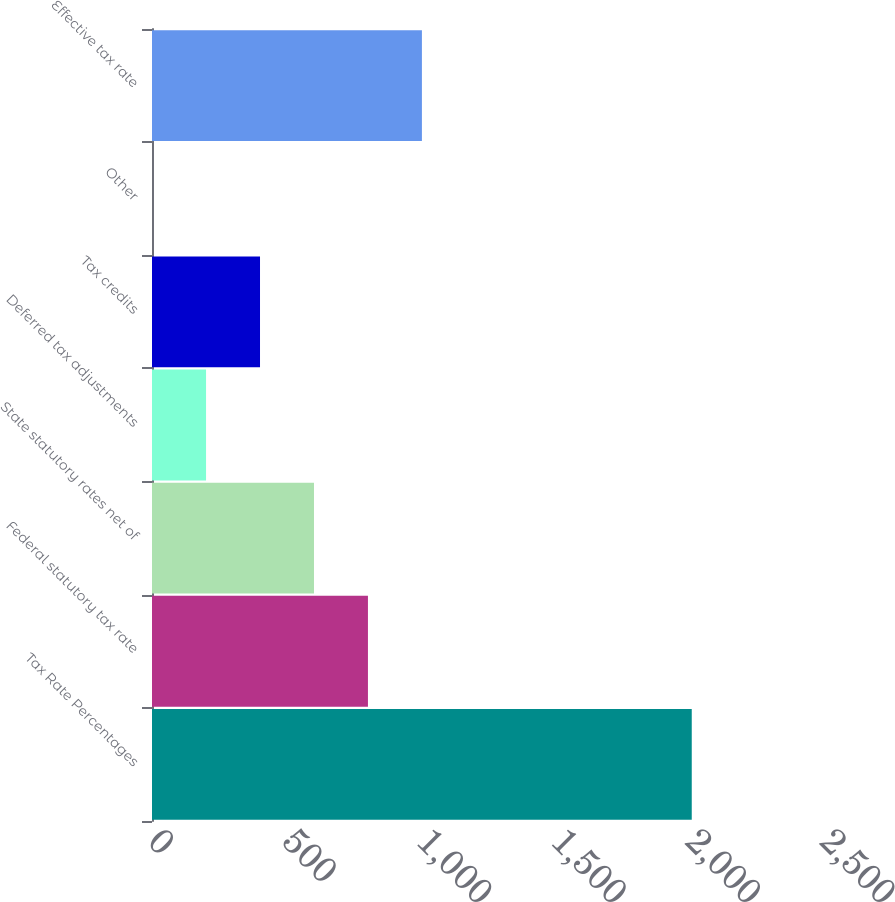<chart> <loc_0><loc_0><loc_500><loc_500><bar_chart><fcel>Tax Rate Percentages<fcel>Federal statutory tax rate<fcel>State statutory rates net of<fcel>Deferred tax adjustments<fcel>Tax credits<fcel>Other<fcel>Effective tax rate<nl><fcel>2008<fcel>803.38<fcel>602.61<fcel>201.07<fcel>401.84<fcel>0.3<fcel>1004.15<nl></chart> 